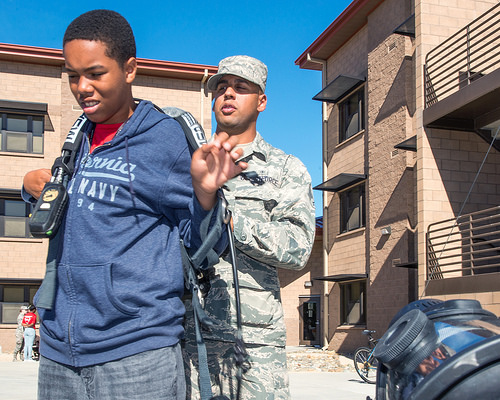<image>
Is the hat on the man? No. The hat is not positioned on the man. They may be near each other, but the hat is not supported by or resting on top of the man. Is there a boy behind the soldier? No. The boy is not behind the soldier. From this viewpoint, the boy appears to be positioned elsewhere in the scene. 